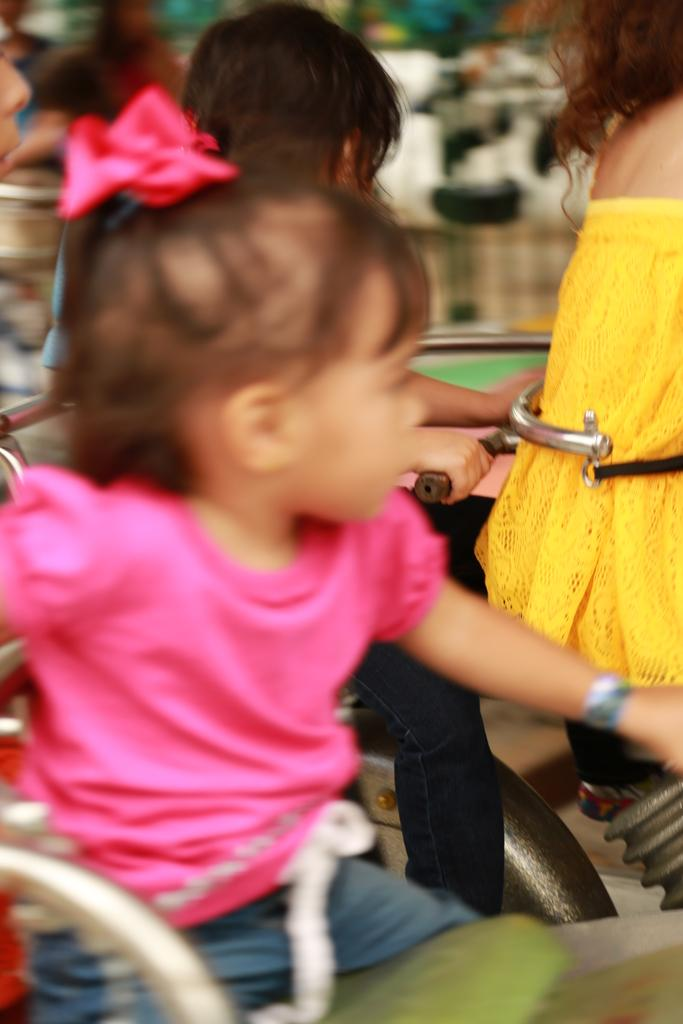What is present in the image? There are kids in the image. What are the kids doing in the image? The kids are sitting in chairs. Where are the chairs located in the image? The chairs are located at the bottom of the image. What type of egg is being used to build a straw structure in the image? There is no egg or straw structure present in the image. How many turkeys can be seen in the image? There are no turkeys present in the image. 